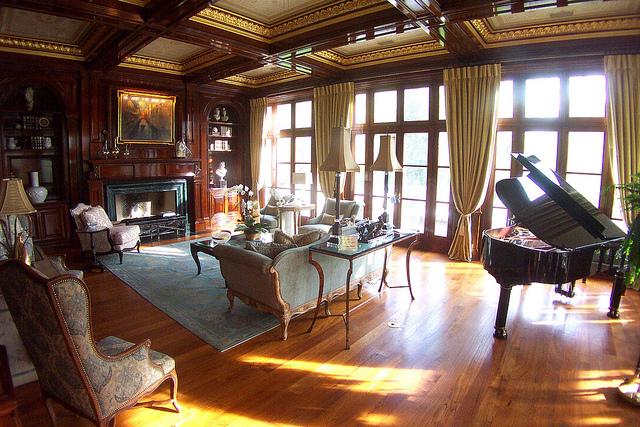Do you think the owner plays the piano?
Short answer required. Yes. What type of flooring is this?
Short answer required. Wood. What room is this?
Quick response, please. Living room. 